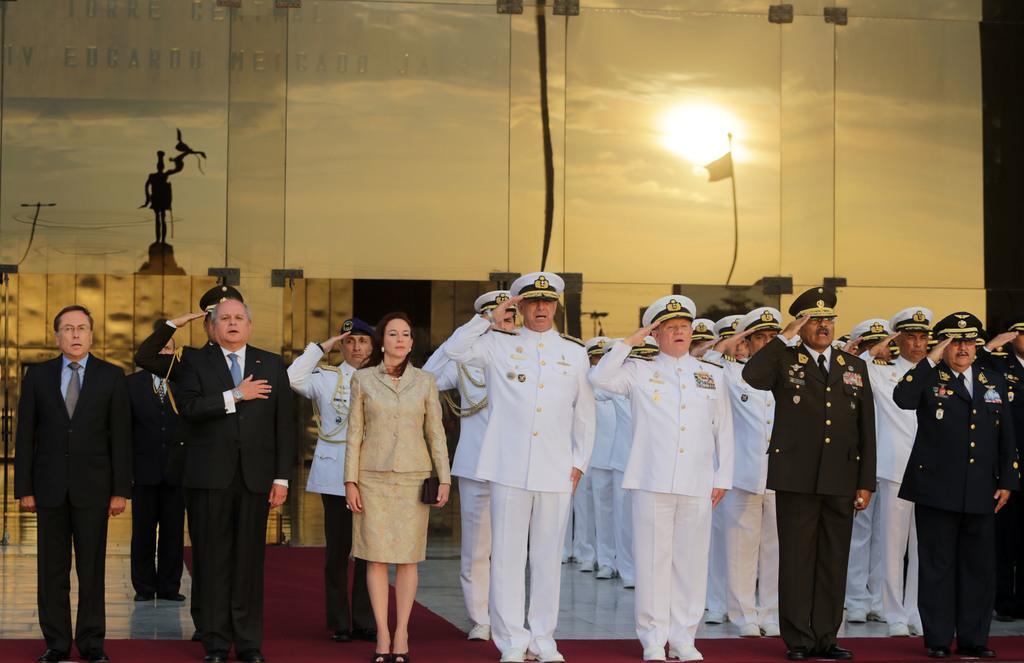Describe this image in one or two sentences. In this image there are group of people standing and some of them are wearing uniforms, and saluting and it seems that they are singing something. In the center there is one woman standing, at the bottom there is floor and in the background there are some boards. On the boards there is text and on the boards we could see reflection of flag, statue, pole, wires and sky. And there are some other objects. 